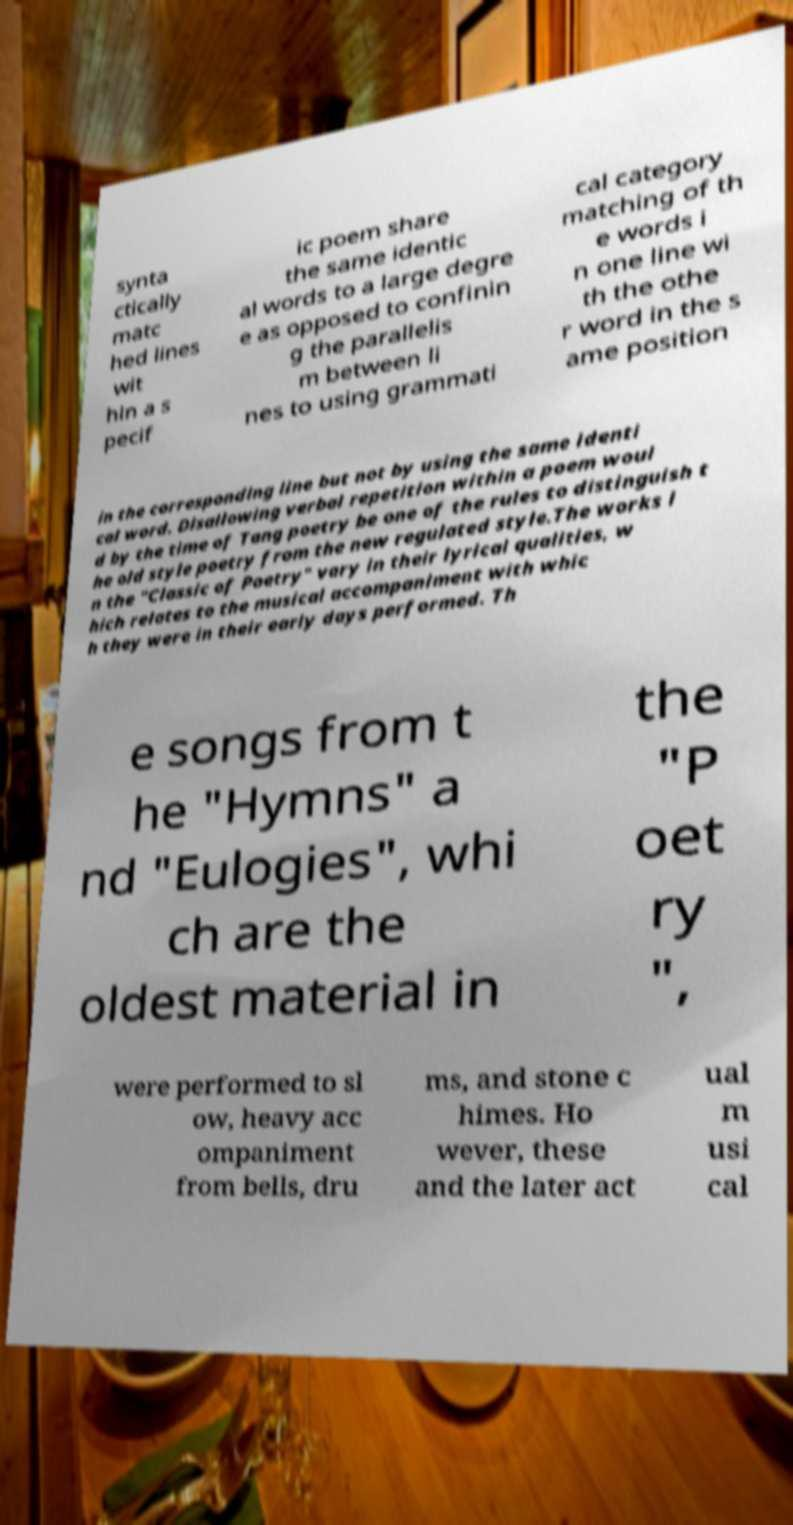Please read and relay the text visible in this image. What does it say? synta ctically matc hed lines wit hin a s pecif ic poem share the same identic al words to a large degre e as opposed to confinin g the parallelis m between li nes to using grammati cal category matching of th e words i n one line wi th the othe r word in the s ame position in the corresponding line but not by using the same identi cal word. Disallowing verbal repetition within a poem woul d by the time of Tang poetry be one of the rules to distinguish t he old style poetry from the new regulated style.The works i n the "Classic of Poetry" vary in their lyrical qualities, w hich relates to the musical accompaniment with whic h they were in their early days performed. Th e songs from t he "Hymns" a nd "Eulogies", whi ch are the oldest material in the "P oet ry ", were performed to sl ow, heavy acc ompaniment from bells, dru ms, and stone c himes. Ho wever, these and the later act ual m usi cal 